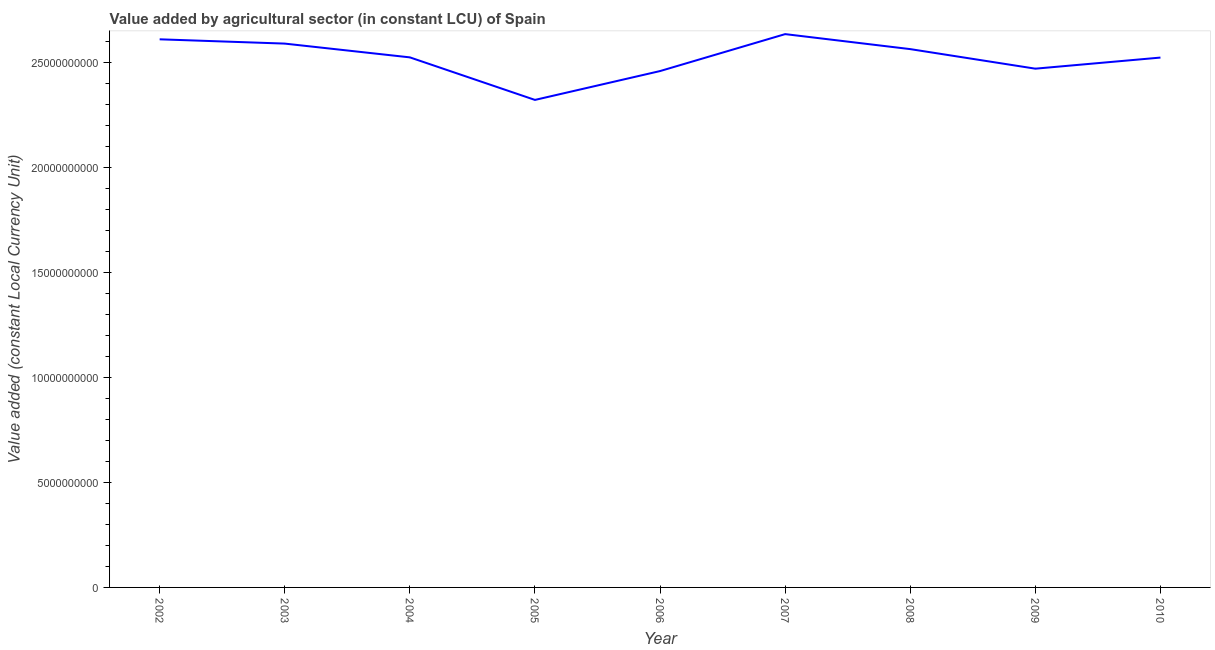What is the value added by agriculture sector in 2007?
Keep it short and to the point. 2.64e+1. Across all years, what is the maximum value added by agriculture sector?
Offer a very short reply. 2.64e+1. Across all years, what is the minimum value added by agriculture sector?
Give a very brief answer. 2.32e+1. What is the sum of the value added by agriculture sector?
Your answer should be very brief. 2.27e+11. What is the difference between the value added by agriculture sector in 2005 and 2008?
Offer a terse response. -2.42e+09. What is the average value added by agriculture sector per year?
Keep it short and to the point. 2.52e+1. What is the median value added by agriculture sector?
Your answer should be very brief. 2.53e+1. In how many years, is the value added by agriculture sector greater than 20000000000 LCU?
Give a very brief answer. 9. Do a majority of the years between 2006 and 2008 (inclusive) have value added by agriculture sector greater than 13000000000 LCU?
Your answer should be compact. Yes. What is the ratio of the value added by agriculture sector in 2003 to that in 2005?
Provide a short and direct response. 1.12. Is the value added by agriculture sector in 2002 less than that in 2008?
Provide a short and direct response. No. Is the difference between the value added by agriculture sector in 2004 and 2005 greater than the difference between any two years?
Provide a short and direct response. No. What is the difference between the highest and the second highest value added by agriculture sector?
Ensure brevity in your answer.  2.48e+08. What is the difference between the highest and the lowest value added by agriculture sector?
Your answer should be compact. 3.14e+09. How many years are there in the graph?
Ensure brevity in your answer.  9. Are the values on the major ticks of Y-axis written in scientific E-notation?
Make the answer very short. No. What is the title of the graph?
Make the answer very short. Value added by agricultural sector (in constant LCU) of Spain. What is the label or title of the X-axis?
Your response must be concise. Year. What is the label or title of the Y-axis?
Offer a very short reply. Value added (constant Local Currency Unit). What is the Value added (constant Local Currency Unit) of 2002?
Give a very brief answer. 2.61e+1. What is the Value added (constant Local Currency Unit) in 2003?
Offer a terse response. 2.59e+1. What is the Value added (constant Local Currency Unit) in 2004?
Make the answer very short. 2.53e+1. What is the Value added (constant Local Currency Unit) of 2005?
Your response must be concise. 2.32e+1. What is the Value added (constant Local Currency Unit) of 2006?
Ensure brevity in your answer.  2.46e+1. What is the Value added (constant Local Currency Unit) of 2007?
Provide a succinct answer. 2.64e+1. What is the Value added (constant Local Currency Unit) of 2008?
Provide a short and direct response. 2.57e+1. What is the Value added (constant Local Currency Unit) in 2009?
Offer a very short reply. 2.47e+1. What is the Value added (constant Local Currency Unit) in 2010?
Give a very brief answer. 2.53e+1. What is the difference between the Value added (constant Local Currency Unit) in 2002 and 2003?
Ensure brevity in your answer.  2.04e+08. What is the difference between the Value added (constant Local Currency Unit) in 2002 and 2004?
Provide a short and direct response. 8.60e+08. What is the difference between the Value added (constant Local Currency Unit) in 2002 and 2005?
Offer a terse response. 2.89e+09. What is the difference between the Value added (constant Local Currency Unit) in 2002 and 2006?
Your answer should be very brief. 1.51e+09. What is the difference between the Value added (constant Local Currency Unit) in 2002 and 2007?
Give a very brief answer. -2.48e+08. What is the difference between the Value added (constant Local Currency Unit) in 2002 and 2008?
Offer a terse response. 4.67e+08. What is the difference between the Value added (constant Local Currency Unit) in 2002 and 2009?
Your answer should be very brief. 1.40e+09. What is the difference between the Value added (constant Local Currency Unit) in 2002 and 2010?
Your answer should be compact. 8.70e+08. What is the difference between the Value added (constant Local Currency Unit) in 2003 and 2004?
Give a very brief answer. 6.56e+08. What is the difference between the Value added (constant Local Currency Unit) in 2003 and 2005?
Keep it short and to the point. 2.68e+09. What is the difference between the Value added (constant Local Currency Unit) in 2003 and 2006?
Your answer should be compact. 1.31e+09. What is the difference between the Value added (constant Local Currency Unit) in 2003 and 2007?
Provide a short and direct response. -4.52e+08. What is the difference between the Value added (constant Local Currency Unit) in 2003 and 2008?
Ensure brevity in your answer.  2.63e+08. What is the difference between the Value added (constant Local Currency Unit) in 2003 and 2009?
Your answer should be compact. 1.20e+09. What is the difference between the Value added (constant Local Currency Unit) in 2003 and 2010?
Provide a short and direct response. 6.66e+08. What is the difference between the Value added (constant Local Currency Unit) in 2004 and 2005?
Offer a very short reply. 2.03e+09. What is the difference between the Value added (constant Local Currency Unit) in 2004 and 2006?
Offer a terse response. 6.53e+08. What is the difference between the Value added (constant Local Currency Unit) in 2004 and 2007?
Keep it short and to the point. -1.11e+09. What is the difference between the Value added (constant Local Currency Unit) in 2004 and 2008?
Keep it short and to the point. -3.93e+08. What is the difference between the Value added (constant Local Currency Unit) in 2004 and 2009?
Your response must be concise. 5.39e+08. What is the difference between the Value added (constant Local Currency Unit) in 2005 and 2006?
Make the answer very short. -1.38e+09. What is the difference between the Value added (constant Local Currency Unit) in 2005 and 2007?
Your response must be concise. -3.14e+09. What is the difference between the Value added (constant Local Currency Unit) in 2005 and 2008?
Your response must be concise. -2.42e+09. What is the difference between the Value added (constant Local Currency Unit) in 2005 and 2009?
Provide a short and direct response. -1.49e+09. What is the difference between the Value added (constant Local Currency Unit) in 2005 and 2010?
Your answer should be compact. -2.02e+09. What is the difference between the Value added (constant Local Currency Unit) in 2006 and 2007?
Keep it short and to the point. -1.76e+09. What is the difference between the Value added (constant Local Currency Unit) in 2006 and 2008?
Offer a very short reply. -1.05e+09. What is the difference between the Value added (constant Local Currency Unit) in 2006 and 2009?
Offer a terse response. -1.14e+08. What is the difference between the Value added (constant Local Currency Unit) in 2006 and 2010?
Offer a terse response. -6.43e+08. What is the difference between the Value added (constant Local Currency Unit) in 2007 and 2008?
Offer a terse response. 7.15e+08. What is the difference between the Value added (constant Local Currency Unit) in 2007 and 2009?
Your answer should be compact. 1.65e+09. What is the difference between the Value added (constant Local Currency Unit) in 2007 and 2010?
Keep it short and to the point. 1.12e+09. What is the difference between the Value added (constant Local Currency Unit) in 2008 and 2009?
Offer a terse response. 9.32e+08. What is the difference between the Value added (constant Local Currency Unit) in 2008 and 2010?
Give a very brief answer. 4.03e+08. What is the difference between the Value added (constant Local Currency Unit) in 2009 and 2010?
Offer a terse response. -5.29e+08. What is the ratio of the Value added (constant Local Currency Unit) in 2002 to that in 2004?
Offer a terse response. 1.03. What is the ratio of the Value added (constant Local Currency Unit) in 2002 to that in 2005?
Make the answer very short. 1.12. What is the ratio of the Value added (constant Local Currency Unit) in 2002 to that in 2006?
Provide a short and direct response. 1.06. What is the ratio of the Value added (constant Local Currency Unit) in 2002 to that in 2007?
Provide a succinct answer. 0.99. What is the ratio of the Value added (constant Local Currency Unit) in 2002 to that in 2009?
Your response must be concise. 1.06. What is the ratio of the Value added (constant Local Currency Unit) in 2002 to that in 2010?
Provide a succinct answer. 1.03. What is the ratio of the Value added (constant Local Currency Unit) in 2003 to that in 2005?
Your answer should be very brief. 1.12. What is the ratio of the Value added (constant Local Currency Unit) in 2003 to that in 2006?
Provide a short and direct response. 1.05. What is the ratio of the Value added (constant Local Currency Unit) in 2003 to that in 2009?
Make the answer very short. 1.05. What is the ratio of the Value added (constant Local Currency Unit) in 2003 to that in 2010?
Offer a terse response. 1.03. What is the ratio of the Value added (constant Local Currency Unit) in 2004 to that in 2005?
Offer a terse response. 1.09. What is the ratio of the Value added (constant Local Currency Unit) in 2004 to that in 2007?
Your answer should be compact. 0.96. What is the ratio of the Value added (constant Local Currency Unit) in 2004 to that in 2009?
Your answer should be compact. 1.02. What is the ratio of the Value added (constant Local Currency Unit) in 2005 to that in 2006?
Keep it short and to the point. 0.94. What is the ratio of the Value added (constant Local Currency Unit) in 2005 to that in 2007?
Make the answer very short. 0.88. What is the ratio of the Value added (constant Local Currency Unit) in 2005 to that in 2008?
Offer a very short reply. 0.91. What is the ratio of the Value added (constant Local Currency Unit) in 2005 to that in 2009?
Keep it short and to the point. 0.94. What is the ratio of the Value added (constant Local Currency Unit) in 2005 to that in 2010?
Keep it short and to the point. 0.92. What is the ratio of the Value added (constant Local Currency Unit) in 2006 to that in 2007?
Your response must be concise. 0.93. What is the ratio of the Value added (constant Local Currency Unit) in 2006 to that in 2008?
Offer a very short reply. 0.96. What is the ratio of the Value added (constant Local Currency Unit) in 2006 to that in 2010?
Offer a very short reply. 0.97. What is the ratio of the Value added (constant Local Currency Unit) in 2007 to that in 2008?
Offer a very short reply. 1.03. What is the ratio of the Value added (constant Local Currency Unit) in 2007 to that in 2009?
Your answer should be compact. 1.07. What is the ratio of the Value added (constant Local Currency Unit) in 2007 to that in 2010?
Offer a terse response. 1.04. What is the ratio of the Value added (constant Local Currency Unit) in 2008 to that in 2009?
Ensure brevity in your answer.  1.04. 